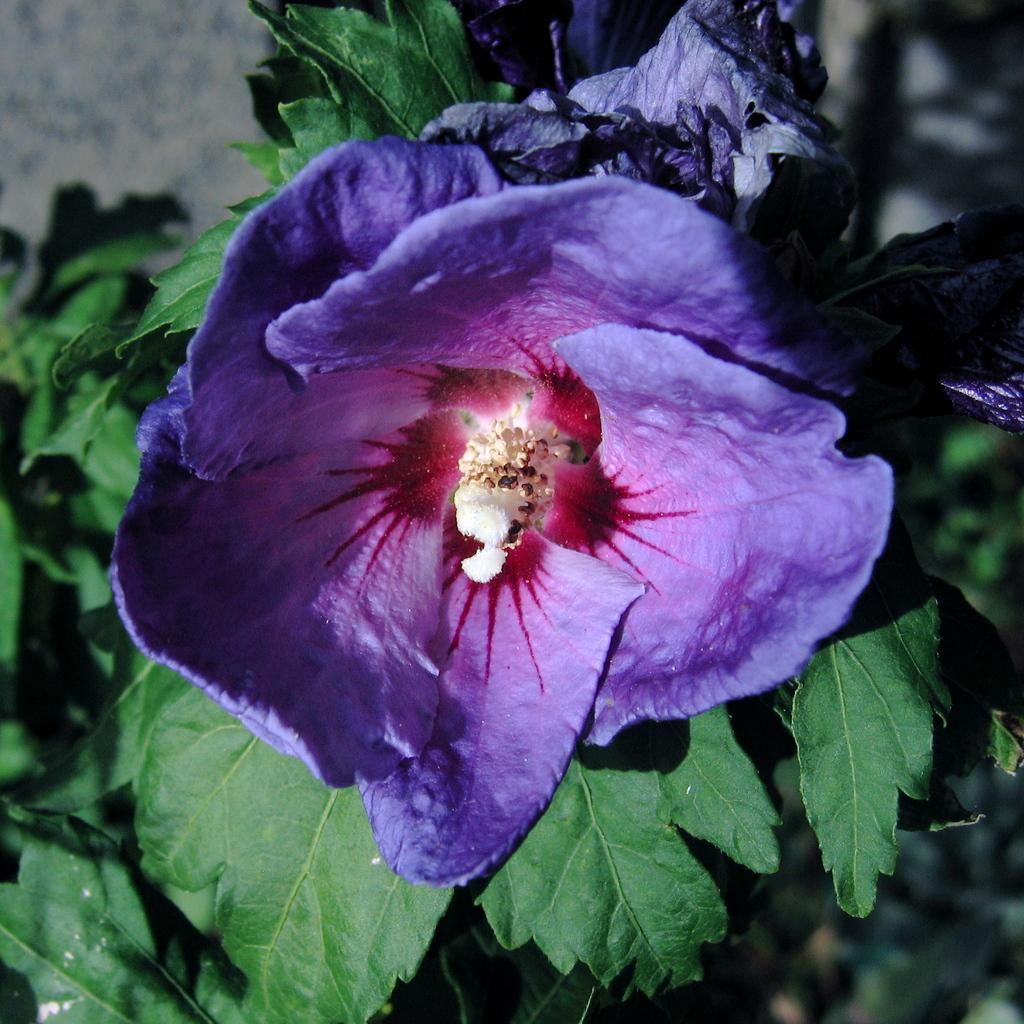What is the main subject of the image? There is a flower in the image. What are the flower's components? The flower has leaves. Where is the flower positioned in the image? The flower is located in the center of the image. What type of zephyr can be seen blowing the flower in the image? There is no zephyr present in the image, and the flower is not shown being blown by any wind. What kind of toys are scattered around the flower in the image? There are no toys present in the image; it only features a flower with leaves. 